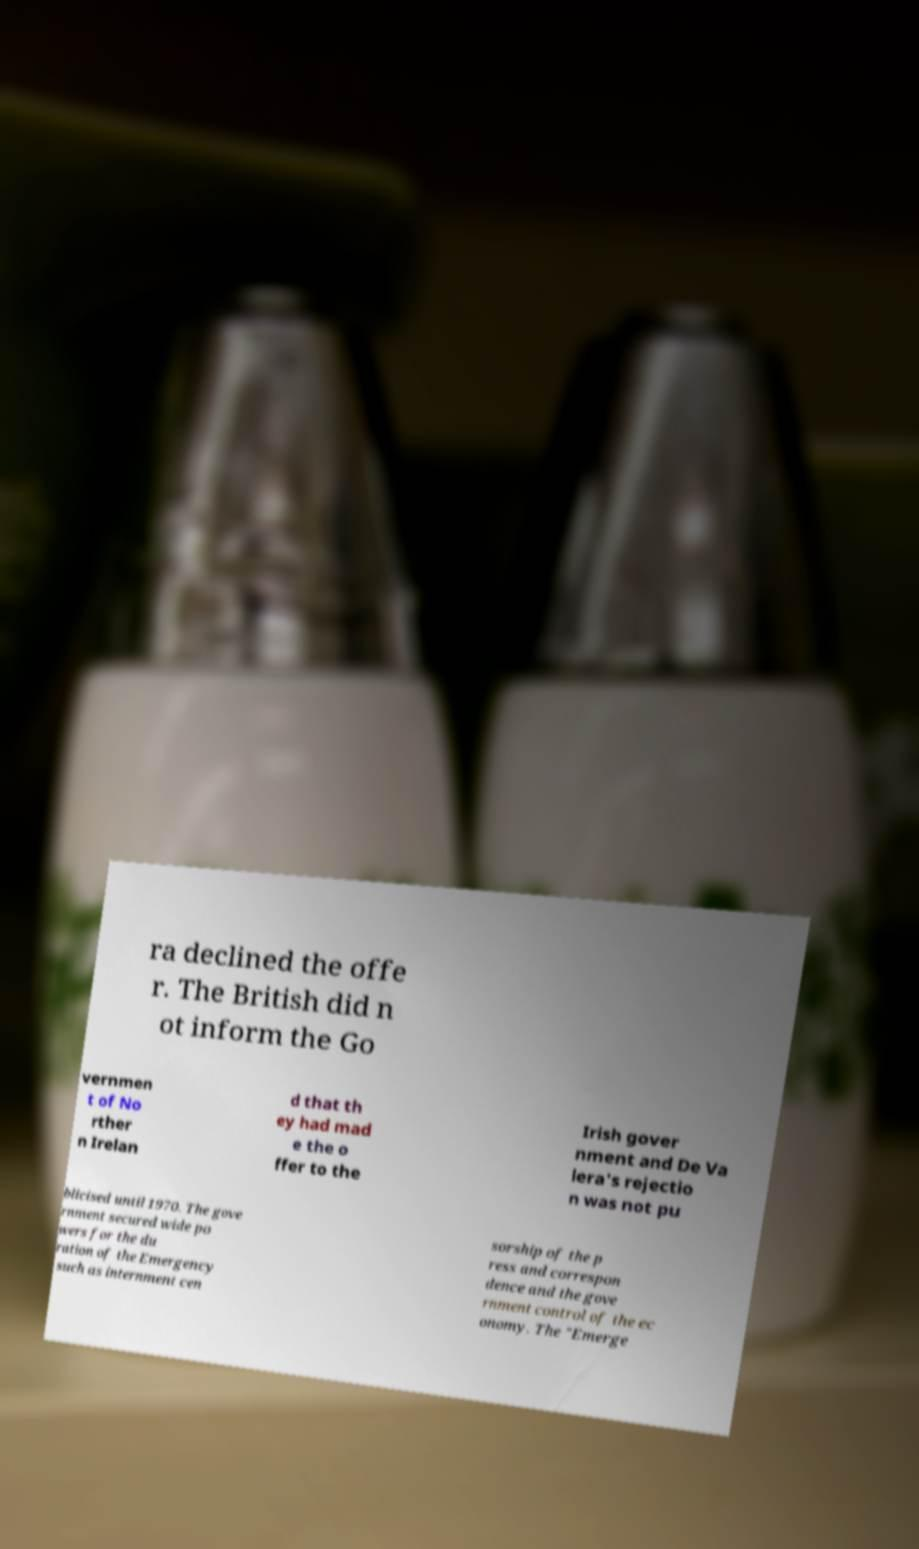Could you extract and type out the text from this image? ra declined the offe r. The British did n ot inform the Go vernmen t of No rther n Irelan d that th ey had mad e the o ffer to the Irish gover nment and De Va lera's rejectio n was not pu blicised until 1970. The gove rnment secured wide po wers for the du ration of the Emergency such as internment cen sorship of the p ress and correspon dence and the gove rnment control of the ec onomy. The "Emerge 